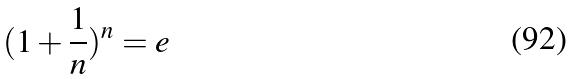Convert formula to latex. <formula><loc_0><loc_0><loc_500><loc_500>( 1 + \frac { 1 } { n } ) ^ { n } = e</formula> 